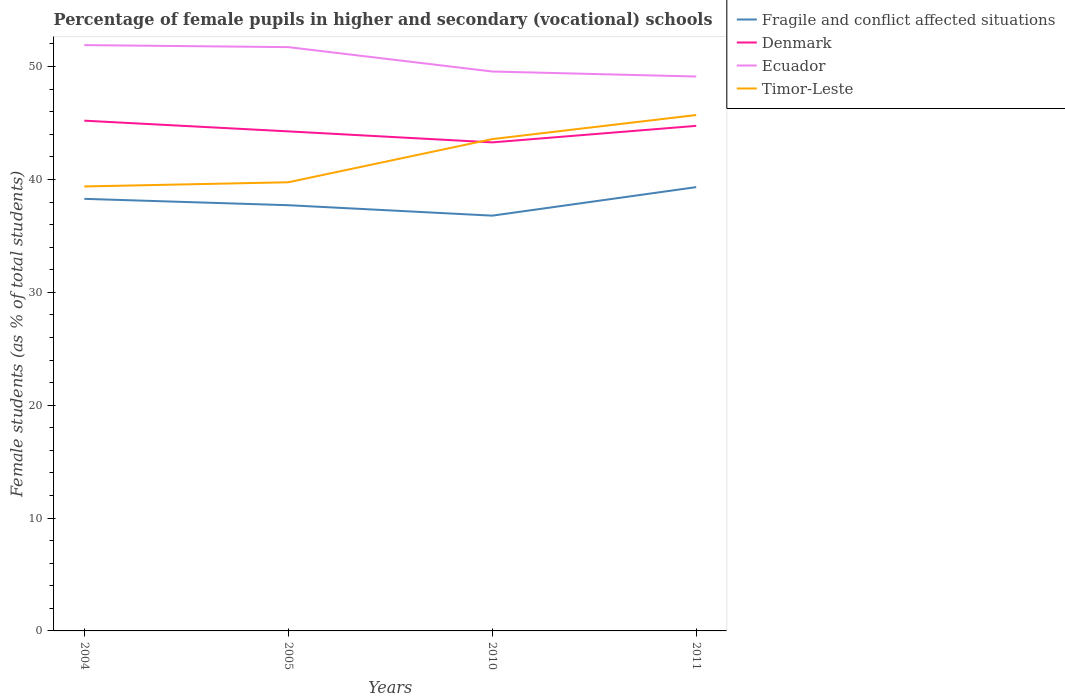How many different coloured lines are there?
Provide a short and direct response. 4. Across all years, what is the maximum percentage of female pupils in higher and secondary schools in Denmark?
Keep it short and to the point. 43.28. What is the total percentage of female pupils in higher and secondary schools in Denmark in the graph?
Provide a short and direct response. 0.95. What is the difference between the highest and the second highest percentage of female pupils in higher and secondary schools in Fragile and conflict affected situations?
Give a very brief answer. 2.53. Is the percentage of female pupils in higher and secondary schools in Denmark strictly greater than the percentage of female pupils in higher and secondary schools in Ecuador over the years?
Provide a short and direct response. Yes. What is the difference between two consecutive major ticks on the Y-axis?
Make the answer very short. 10. Are the values on the major ticks of Y-axis written in scientific E-notation?
Keep it short and to the point. No. Does the graph contain any zero values?
Give a very brief answer. No. Does the graph contain grids?
Offer a very short reply. No. How many legend labels are there?
Offer a very short reply. 4. How are the legend labels stacked?
Your answer should be very brief. Vertical. What is the title of the graph?
Offer a terse response. Percentage of female pupils in higher and secondary (vocational) schools. What is the label or title of the X-axis?
Your response must be concise. Years. What is the label or title of the Y-axis?
Your answer should be very brief. Female students (as % of total students). What is the Female students (as % of total students) of Fragile and conflict affected situations in 2004?
Your answer should be very brief. 38.28. What is the Female students (as % of total students) of Denmark in 2004?
Provide a succinct answer. 45.21. What is the Female students (as % of total students) in Ecuador in 2004?
Give a very brief answer. 51.9. What is the Female students (as % of total students) in Timor-Leste in 2004?
Ensure brevity in your answer.  39.38. What is the Female students (as % of total students) in Fragile and conflict affected situations in 2005?
Your answer should be very brief. 37.72. What is the Female students (as % of total students) in Denmark in 2005?
Make the answer very short. 44.26. What is the Female students (as % of total students) of Ecuador in 2005?
Provide a succinct answer. 51.72. What is the Female students (as % of total students) of Timor-Leste in 2005?
Keep it short and to the point. 39.75. What is the Female students (as % of total students) of Fragile and conflict affected situations in 2010?
Provide a succinct answer. 36.79. What is the Female students (as % of total students) of Denmark in 2010?
Your answer should be very brief. 43.28. What is the Female students (as % of total students) of Ecuador in 2010?
Give a very brief answer. 49.56. What is the Female students (as % of total students) of Timor-Leste in 2010?
Provide a succinct answer. 43.57. What is the Female students (as % of total students) in Fragile and conflict affected situations in 2011?
Offer a very short reply. 39.32. What is the Female students (as % of total students) of Denmark in 2011?
Provide a short and direct response. 44.75. What is the Female students (as % of total students) of Ecuador in 2011?
Ensure brevity in your answer.  49.12. What is the Female students (as % of total students) of Timor-Leste in 2011?
Ensure brevity in your answer.  45.71. Across all years, what is the maximum Female students (as % of total students) in Fragile and conflict affected situations?
Offer a terse response. 39.32. Across all years, what is the maximum Female students (as % of total students) in Denmark?
Your answer should be very brief. 45.21. Across all years, what is the maximum Female students (as % of total students) in Ecuador?
Provide a succinct answer. 51.9. Across all years, what is the maximum Female students (as % of total students) in Timor-Leste?
Provide a short and direct response. 45.71. Across all years, what is the minimum Female students (as % of total students) of Fragile and conflict affected situations?
Provide a succinct answer. 36.79. Across all years, what is the minimum Female students (as % of total students) in Denmark?
Offer a very short reply. 43.28. Across all years, what is the minimum Female students (as % of total students) of Ecuador?
Make the answer very short. 49.12. Across all years, what is the minimum Female students (as % of total students) in Timor-Leste?
Keep it short and to the point. 39.38. What is the total Female students (as % of total students) of Fragile and conflict affected situations in the graph?
Provide a short and direct response. 152.11. What is the total Female students (as % of total students) in Denmark in the graph?
Provide a short and direct response. 177.49. What is the total Female students (as % of total students) in Ecuador in the graph?
Your response must be concise. 202.3. What is the total Female students (as % of total students) in Timor-Leste in the graph?
Offer a terse response. 168.41. What is the difference between the Female students (as % of total students) of Fragile and conflict affected situations in 2004 and that in 2005?
Your response must be concise. 0.56. What is the difference between the Female students (as % of total students) in Denmark in 2004 and that in 2005?
Provide a succinct answer. 0.95. What is the difference between the Female students (as % of total students) of Ecuador in 2004 and that in 2005?
Provide a succinct answer. 0.18. What is the difference between the Female students (as % of total students) of Timor-Leste in 2004 and that in 2005?
Give a very brief answer. -0.37. What is the difference between the Female students (as % of total students) of Fragile and conflict affected situations in 2004 and that in 2010?
Your answer should be very brief. 1.49. What is the difference between the Female students (as % of total students) of Denmark in 2004 and that in 2010?
Offer a terse response. 1.92. What is the difference between the Female students (as % of total students) of Ecuador in 2004 and that in 2010?
Offer a very short reply. 2.34. What is the difference between the Female students (as % of total students) of Timor-Leste in 2004 and that in 2010?
Your response must be concise. -4.2. What is the difference between the Female students (as % of total students) in Fragile and conflict affected situations in 2004 and that in 2011?
Your answer should be very brief. -1.04. What is the difference between the Female students (as % of total students) in Denmark in 2004 and that in 2011?
Your answer should be very brief. 0.46. What is the difference between the Female students (as % of total students) of Ecuador in 2004 and that in 2011?
Give a very brief answer. 2.78. What is the difference between the Female students (as % of total students) of Timor-Leste in 2004 and that in 2011?
Keep it short and to the point. -6.33. What is the difference between the Female students (as % of total students) in Fragile and conflict affected situations in 2005 and that in 2010?
Your response must be concise. 0.93. What is the difference between the Female students (as % of total students) in Denmark in 2005 and that in 2010?
Your response must be concise. 0.97. What is the difference between the Female students (as % of total students) of Ecuador in 2005 and that in 2010?
Provide a succinct answer. 2.16. What is the difference between the Female students (as % of total students) of Timor-Leste in 2005 and that in 2010?
Make the answer very short. -3.82. What is the difference between the Female students (as % of total students) of Fragile and conflict affected situations in 2005 and that in 2011?
Provide a short and direct response. -1.6. What is the difference between the Female students (as % of total students) of Denmark in 2005 and that in 2011?
Keep it short and to the point. -0.49. What is the difference between the Female students (as % of total students) in Ecuador in 2005 and that in 2011?
Offer a very short reply. 2.6. What is the difference between the Female students (as % of total students) of Timor-Leste in 2005 and that in 2011?
Your answer should be compact. -5.96. What is the difference between the Female students (as % of total students) in Fragile and conflict affected situations in 2010 and that in 2011?
Ensure brevity in your answer.  -2.53. What is the difference between the Female students (as % of total students) in Denmark in 2010 and that in 2011?
Offer a very short reply. -1.46. What is the difference between the Female students (as % of total students) of Ecuador in 2010 and that in 2011?
Provide a short and direct response. 0.44. What is the difference between the Female students (as % of total students) in Timor-Leste in 2010 and that in 2011?
Make the answer very short. -2.13. What is the difference between the Female students (as % of total students) of Fragile and conflict affected situations in 2004 and the Female students (as % of total students) of Denmark in 2005?
Provide a short and direct response. -5.98. What is the difference between the Female students (as % of total students) in Fragile and conflict affected situations in 2004 and the Female students (as % of total students) in Ecuador in 2005?
Provide a short and direct response. -13.44. What is the difference between the Female students (as % of total students) in Fragile and conflict affected situations in 2004 and the Female students (as % of total students) in Timor-Leste in 2005?
Your response must be concise. -1.47. What is the difference between the Female students (as % of total students) in Denmark in 2004 and the Female students (as % of total students) in Ecuador in 2005?
Your answer should be very brief. -6.52. What is the difference between the Female students (as % of total students) of Denmark in 2004 and the Female students (as % of total students) of Timor-Leste in 2005?
Offer a very short reply. 5.46. What is the difference between the Female students (as % of total students) of Ecuador in 2004 and the Female students (as % of total students) of Timor-Leste in 2005?
Provide a short and direct response. 12.15. What is the difference between the Female students (as % of total students) of Fragile and conflict affected situations in 2004 and the Female students (as % of total students) of Denmark in 2010?
Ensure brevity in your answer.  -5. What is the difference between the Female students (as % of total students) of Fragile and conflict affected situations in 2004 and the Female students (as % of total students) of Ecuador in 2010?
Offer a terse response. -11.28. What is the difference between the Female students (as % of total students) in Fragile and conflict affected situations in 2004 and the Female students (as % of total students) in Timor-Leste in 2010?
Your answer should be compact. -5.29. What is the difference between the Female students (as % of total students) of Denmark in 2004 and the Female students (as % of total students) of Ecuador in 2010?
Your answer should be compact. -4.36. What is the difference between the Female students (as % of total students) of Denmark in 2004 and the Female students (as % of total students) of Timor-Leste in 2010?
Give a very brief answer. 1.63. What is the difference between the Female students (as % of total students) in Ecuador in 2004 and the Female students (as % of total students) in Timor-Leste in 2010?
Offer a very short reply. 8.33. What is the difference between the Female students (as % of total students) in Fragile and conflict affected situations in 2004 and the Female students (as % of total students) in Denmark in 2011?
Provide a succinct answer. -6.47. What is the difference between the Female students (as % of total students) of Fragile and conflict affected situations in 2004 and the Female students (as % of total students) of Ecuador in 2011?
Ensure brevity in your answer.  -10.84. What is the difference between the Female students (as % of total students) in Fragile and conflict affected situations in 2004 and the Female students (as % of total students) in Timor-Leste in 2011?
Provide a short and direct response. -7.43. What is the difference between the Female students (as % of total students) in Denmark in 2004 and the Female students (as % of total students) in Ecuador in 2011?
Keep it short and to the point. -3.91. What is the difference between the Female students (as % of total students) in Denmark in 2004 and the Female students (as % of total students) in Timor-Leste in 2011?
Give a very brief answer. -0.5. What is the difference between the Female students (as % of total students) in Ecuador in 2004 and the Female students (as % of total students) in Timor-Leste in 2011?
Make the answer very short. 6.2. What is the difference between the Female students (as % of total students) of Fragile and conflict affected situations in 2005 and the Female students (as % of total students) of Denmark in 2010?
Your answer should be very brief. -5.57. What is the difference between the Female students (as % of total students) of Fragile and conflict affected situations in 2005 and the Female students (as % of total students) of Ecuador in 2010?
Make the answer very short. -11.84. What is the difference between the Female students (as % of total students) of Fragile and conflict affected situations in 2005 and the Female students (as % of total students) of Timor-Leste in 2010?
Your answer should be compact. -5.86. What is the difference between the Female students (as % of total students) of Denmark in 2005 and the Female students (as % of total students) of Ecuador in 2010?
Offer a terse response. -5.3. What is the difference between the Female students (as % of total students) of Denmark in 2005 and the Female students (as % of total students) of Timor-Leste in 2010?
Keep it short and to the point. 0.68. What is the difference between the Female students (as % of total students) in Ecuador in 2005 and the Female students (as % of total students) in Timor-Leste in 2010?
Your answer should be very brief. 8.15. What is the difference between the Female students (as % of total students) in Fragile and conflict affected situations in 2005 and the Female students (as % of total students) in Denmark in 2011?
Your answer should be very brief. -7.03. What is the difference between the Female students (as % of total students) of Fragile and conflict affected situations in 2005 and the Female students (as % of total students) of Ecuador in 2011?
Ensure brevity in your answer.  -11.4. What is the difference between the Female students (as % of total students) of Fragile and conflict affected situations in 2005 and the Female students (as % of total students) of Timor-Leste in 2011?
Your answer should be compact. -7.99. What is the difference between the Female students (as % of total students) of Denmark in 2005 and the Female students (as % of total students) of Ecuador in 2011?
Your response must be concise. -4.86. What is the difference between the Female students (as % of total students) in Denmark in 2005 and the Female students (as % of total students) in Timor-Leste in 2011?
Offer a terse response. -1.45. What is the difference between the Female students (as % of total students) of Ecuador in 2005 and the Female students (as % of total students) of Timor-Leste in 2011?
Ensure brevity in your answer.  6.02. What is the difference between the Female students (as % of total students) of Fragile and conflict affected situations in 2010 and the Female students (as % of total students) of Denmark in 2011?
Make the answer very short. -7.96. What is the difference between the Female students (as % of total students) of Fragile and conflict affected situations in 2010 and the Female students (as % of total students) of Ecuador in 2011?
Your answer should be very brief. -12.33. What is the difference between the Female students (as % of total students) of Fragile and conflict affected situations in 2010 and the Female students (as % of total students) of Timor-Leste in 2011?
Offer a very short reply. -8.91. What is the difference between the Female students (as % of total students) in Denmark in 2010 and the Female students (as % of total students) in Ecuador in 2011?
Provide a succinct answer. -5.84. What is the difference between the Female students (as % of total students) of Denmark in 2010 and the Female students (as % of total students) of Timor-Leste in 2011?
Offer a very short reply. -2.42. What is the difference between the Female students (as % of total students) of Ecuador in 2010 and the Female students (as % of total students) of Timor-Leste in 2011?
Offer a terse response. 3.86. What is the average Female students (as % of total students) in Fragile and conflict affected situations per year?
Your answer should be very brief. 38.03. What is the average Female students (as % of total students) of Denmark per year?
Make the answer very short. 44.37. What is the average Female students (as % of total students) of Ecuador per year?
Your answer should be compact. 50.58. What is the average Female students (as % of total students) of Timor-Leste per year?
Your answer should be very brief. 42.1. In the year 2004, what is the difference between the Female students (as % of total students) of Fragile and conflict affected situations and Female students (as % of total students) of Denmark?
Offer a very short reply. -6.93. In the year 2004, what is the difference between the Female students (as % of total students) in Fragile and conflict affected situations and Female students (as % of total students) in Ecuador?
Offer a terse response. -13.62. In the year 2004, what is the difference between the Female students (as % of total students) in Fragile and conflict affected situations and Female students (as % of total students) in Timor-Leste?
Make the answer very short. -1.1. In the year 2004, what is the difference between the Female students (as % of total students) of Denmark and Female students (as % of total students) of Ecuador?
Keep it short and to the point. -6.7. In the year 2004, what is the difference between the Female students (as % of total students) in Denmark and Female students (as % of total students) in Timor-Leste?
Ensure brevity in your answer.  5.83. In the year 2004, what is the difference between the Female students (as % of total students) in Ecuador and Female students (as % of total students) in Timor-Leste?
Give a very brief answer. 12.52. In the year 2005, what is the difference between the Female students (as % of total students) in Fragile and conflict affected situations and Female students (as % of total students) in Denmark?
Keep it short and to the point. -6.54. In the year 2005, what is the difference between the Female students (as % of total students) in Fragile and conflict affected situations and Female students (as % of total students) in Ecuador?
Your answer should be very brief. -14. In the year 2005, what is the difference between the Female students (as % of total students) of Fragile and conflict affected situations and Female students (as % of total students) of Timor-Leste?
Ensure brevity in your answer.  -2.03. In the year 2005, what is the difference between the Female students (as % of total students) in Denmark and Female students (as % of total students) in Ecuador?
Ensure brevity in your answer.  -7.46. In the year 2005, what is the difference between the Female students (as % of total students) in Denmark and Female students (as % of total students) in Timor-Leste?
Your response must be concise. 4.51. In the year 2005, what is the difference between the Female students (as % of total students) of Ecuador and Female students (as % of total students) of Timor-Leste?
Make the answer very short. 11.97. In the year 2010, what is the difference between the Female students (as % of total students) of Fragile and conflict affected situations and Female students (as % of total students) of Denmark?
Your answer should be very brief. -6.49. In the year 2010, what is the difference between the Female students (as % of total students) in Fragile and conflict affected situations and Female students (as % of total students) in Ecuador?
Your answer should be very brief. -12.77. In the year 2010, what is the difference between the Female students (as % of total students) of Fragile and conflict affected situations and Female students (as % of total students) of Timor-Leste?
Provide a short and direct response. -6.78. In the year 2010, what is the difference between the Female students (as % of total students) of Denmark and Female students (as % of total students) of Ecuador?
Ensure brevity in your answer.  -6.28. In the year 2010, what is the difference between the Female students (as % of total students) of Denmark and Female students (as % of total students) of Timor-Leste?
Ensure brevity in your answer.  -0.29. In the year 2010, what is the difference between the Female students (as % of total students) of Ecuador and Female students (as % of total students) of Timor-Leste?
Keep it short and to the point. 5.99. In the year 2011, what is the difference between the Female students (as % of total students) in Fragile and conflict affected situations and Female students (as % of total students) in Denmark?
Ensure brevity in your answer.  -5.43. In the year 2011, what is the difference between the Female students (as % of total students) of Fragile and conflict affected situations and Female students (as % of total students) of Ecuador?
Make the answer very short. -9.8. In the year 2011, what is the difference between the Female students (as % of total students) of Fragile and conflict affected situations and Female students (as % of total students) of Timor-Leste?
Your response must be concise. -6.39. In the year 2011, what is the difference between the Female students (as % of total students) of Denmark and Female students (as % of total students) of Ecuador?
Your response must be concise. -4.37. In the year 2011, what is the difference between the Female students (as % of total students) in Denmark and Female students (as % of total students) in Timor-Leste?
Keep it short and to the point. -0.96. In the year 2011, what is the difference between the Female students (as % of total students) in Ecuador and Female students (as % of total students) in Timor-Leste?
Give a very brief answer. 3.41. What is the ratio of the Female students (as % of total students) in Fragile and conflict affected situations in 2004 to that in 2005?
Ensure brevity in your answer.  1.01. What is the ratio of the Female students (as % of total students) of Denmark in 2004 to that in 2005?
Your answer should be compact. 1.02. What is the ratio of the Female students (as % of total students) in Timor-Leste in 2004 to that in 2005?
Keep it short and to the point. 0.99. What is the ratio of the Female students (as % of total students) of Fragile and conflict affected situations in 2004 to that in 2010?
Give a very brief answer. 1.04. What is the ratio of the Female students (as % of total students) in Denmark in 2004 to that in 2010?
Provide a succinct answer. 1.04. What is the ratio of the Female students (as % of total students) in Ecuador in 2004 to that in 2010?
Keep it short and to the point. 1.05. What is the ratio of the Female students (as % of total students) of Timor-Leste in 2004 to that in 2010?
Offer a very short reply. 0.9. What is the ratio of the Female students (as % of total students) of Fragile and conflict affected situations in 2004 to that in 2011?
Give a very brief answer. 0.97. What is the ratio of the Female students (as % of total students) in Denmark in 2004 to that in 2011?
Make the answer very short. 1.01. What is the ratio of the Female students (as % of total students) of Ecuador in 2004 to that in 2011?
Your answer should be compact. 1.06. What is the ratio of the Female students (as % of total students) in Timor-Leste in 2004 to that in 2011?
Your answer should be very brief. 0.86. What is the ratio of the Female students (as % of total students) of Fragile and conflict affected situations in 2005 to that in 2010?
Ensure brevity in your answer.  1.03. What is the ratio of the Female students (as % of total students) in Denmark in 2005 to that in 2010?
Provide a short and direct response. 1.02. What is the ratio of the Female students (as % of total students) of Ecuador in 2005 to that in 2010?
Your answer should be compact. 1.04. What is the ratio of the Female students (as % of total students) of Timor-Leste in 2005 to that in 2010?
Your answer should be very brief. 0.91. What is the ratio of the Female students (as % of total students) in Fragile and conflict affected situations in 2005 to that in 2011?
Keep it short and to the point. 0.96. What is the ratio of the Female students (as % of total students) of Denmark in 2005 to that in 2011?
Ensure brevity in your answer.  0.99. What is the ratio of the Female students (as % of total students) in Ecuador in 2005 to that in 2011?
Make the answer very short. 1.05. What is the ratio of the Female students (as % of total students) of Timor-Leste in 2005 to that in 2011?
Offer a terse response. 0.87. What is the ratio of the Female students (as % of total students) in Fragile and conflict affected situations in 2010 to that in 2011?
Your response must be concise. 0.94. What is the ratio of the Female students (as % of total students) of Denmark in 2010 to that in 2011?
Your response must be concise. 0.97. What is the ratio of the Female students (as % of total students) of Ecuador in 2010 to that in 2011?
Keep it short and to the point. 1.01. What is the ratio of the Female students (as % of total students) of Timor-Leste in 2010 to that in 2011?
Your response must be concise. 0.95. What is the difference between the highest and the second highest Female students (as % of total students) in Fragile and conflict affected situations?
Give a very brief answer. 1.04. What is the difference between the highest and the second highest Female students (as % of total students) of Denmark?
Provide a short and direct response. 0.46. What is the difference between the highest and the second highest Female students (as % of total students) of Ecuador?
Provide a succinct answer. 0.18. What is the difference between the highest and the second highest Female students (as % of total students) of Timor-Leste?
Offer a very short reply. 2.13. What is the difference between the highest and the lowest Female students (as % of total students) of Fragile and conflict affected situations?
Your answer should be compact. 2.53. What is the difference between the highest and the lowest Female students (as % of total students) in Denmark?
Offer a terse response. 1.92. What is the difference between the highest and the lowest Female students (as % of total students) of Ecuador?
Offer a terse response. 2.78. What is the difference between the highest and the lowest Female students (as % of total students) of Timor-Leste?
Make the answer very short. 6.33. 